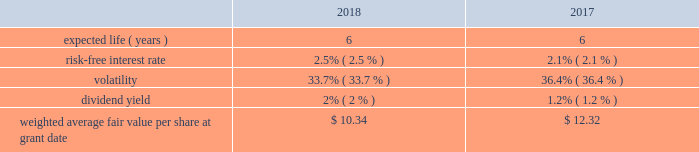Bhge 2018 form 10-k | 85 it is expected that the amount of unrecognized tax benefits will change in the next twelve months due to expiring statutes , audit activity , tax payments , and competent authority proceedings related to transfer pricing or final decisions in matters that are the subject of litigation in various taxing jurisdictions in which we operate .
At december 31 , 2018 , we had approximately $ 96 million of tax liabilities , net of $ 1 million of tax assets , related to uncertain tax positions , each of which are individually insignificant , and each of which are reasonably possible of being settled within the next twelve months .
We conduct business in more than 120 countries and are subject to income taxes in most taxing jurisdictions in which we operate .
All internal revenue service examinations have been completed and closed through year end 2015 for the most significant u.s .
Returns .
We believe there are no other jurisdictions in which the outcome of unresolved issues or claims is likely to be material to our results of operations , financial position or cash flows .
We further believe that we have made adequate provision for all income tax uncertainties .
Note 13 .
Stock-based compensation in july 2017 , we adopted the bhge 2017 long-term incentive plan ( lti plan ) under which we may grant stock options and other equity-based awards to employees and non-employee directors providing services to the company and our subsidiaries .
A total of up to 57.4 million shares of class a common stock are authorized for issuance pursuant to awards granted under the lti plan over its term which expires on the date of the annual meeting of the company in 2027 .
A total of 46.2 million shares of class a common stock are available for issuance as of december 31 , 2018 .
Stock-based compensation cost was $ 121 million and $ 37 million in 2018 and 2017 , respectively .
Stock-based compensation cost is measured at the date of grant based on the calculated fair value of the award and is generally recognized on a straight-line basis over the vesting period of the equity grant .
The compensation cost is determined based on awards ultimately expected to vest ; therefore , we have reduced the cost for estimated forfeitures based on historical forfeiture rates .
Forfeitures are estimated at the time of grant and revised , if necessary , in subsequent periods to reflect actual forfeitures .
There were no stock-based compensation costs capitalized as the amounts were not material .
Stock options we may grant stock options to our officers , directors and key employees .
Stock options generally vest in equal amounts over a three-year vesting period provided that the employee has remained continuously employed by the company through such vesting date .
The fair value of each stock option granted is estimated using the black- scholes option pricing model .
The table presents the weighted average assumptions used in the option pricing model for options granted under the lti plan .
The expected life of the options represents the period of time the options are expected to be outstanding .
The expected life is based on a simple average of the vesting term and original contractual term of the awards .
The expected volatility is based on the historical volatility of our five main competitors over a six year period .
The risk-free interest rate is based on the observed u.s .
Treasury yield curve in effect at the time the options were granted .
The dividend yield is based on a five year history of dividend payouts in baker hughes. .
Baker hughes , a ge company notes to consolidated and combined financial statements .
What portion of the authorized shares under the lti plan is issued as of december 31 , 2018? 
Computations: ((57.4 - 46.2) / 57.4)
Answer: 0.19512. 